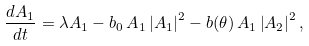<formula> <loc_0><loc_0><loc_500><loc_500>\frac { d A _ { 1 } } { d t } = \lambda A _ { 1 } - b _ { 0 } { \, A } _ { 1 } \left | A _ { 1 } \right | ^ { 2 } - b ( \theta ) { \, A } _ { 1 } \left | A _ { 2 } \right | ^ { 2 } ,</formula> 